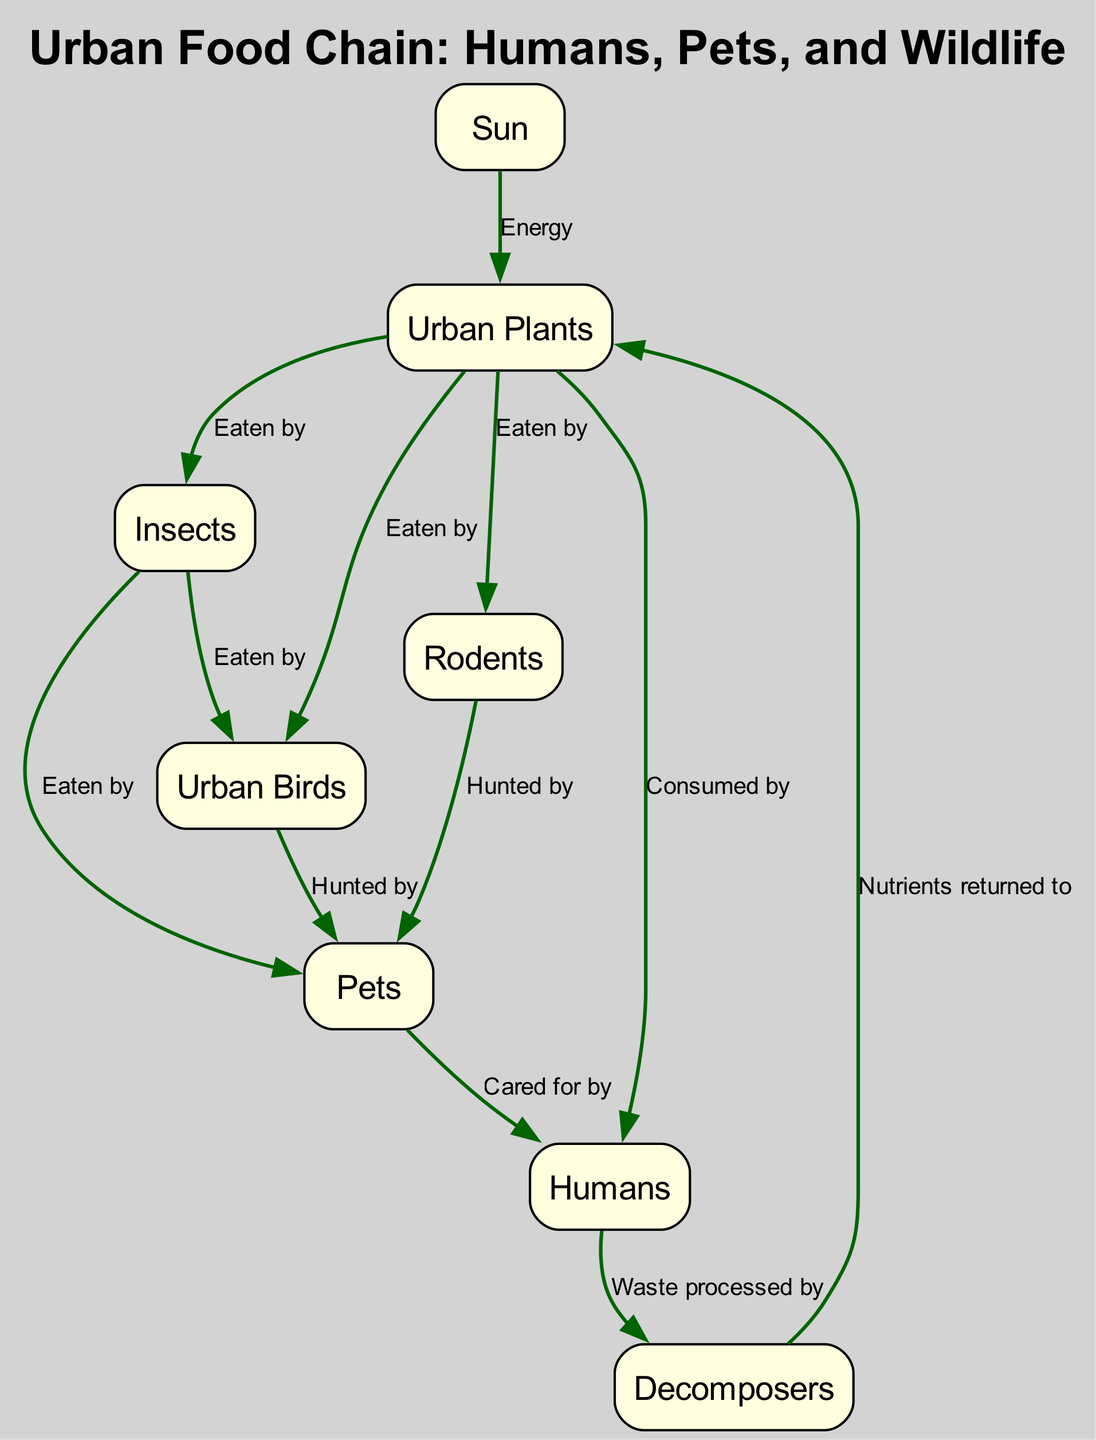What is the primary energy source in the urban food chain? According to the diagram, the primary energy source for all life is indicated as the "Sun." This is the starting point for the food chain and is shown at the top of the diagram.
Answer: Sun How many nodes are present in the urban food chain? The diagram lists a total of seven distinct nodes, which include the Sun, Urban Plants, Insects, Birds, Rodents, Pets, and Humans. Each represents an important element in the food chain.
Answer: 7 What do urban plants provide for insects? The diagram states that urban plants are "Eaten by" insects. This indicates that insects derive their energy and nutrients from consuming urban plants.
Answer: Eaten by Who cares for pets in the urban food chain? The relationship indicated in the diagram shows that pets are "Cared for by" humans. This establishes a direct link where humans take care of their pets in an urban setting.
Answer: Humans What role do decomposers play in the urban food chain? The diagram explains that decomposers process waste from humans, which returns nutrients to plants. This role is crucial as it sustains the cycle of nutrients within the food chain.
Answer: Nutrients returned to Which animals are hunted by pets according to the diagram? The diagram shows that pets hunt both birds and rodents. This illustrates the predatory behavior that pets exhibit towards these urban wildlife elements.
Answer: Birds and Rodents What do humans consume in the urban food chain? The diagram indicates that humans "Consume" urban plants, highlighting their role as primary consumers within the food chain.
Answer: Urban Plants How do nutrients get returned to plants in the urban food chain? According to the diagram, nutrients are returned to plants by decomposers that process waste generated by humans. This connection underlines the recycling of nutrients in the ecosystem.
Answer: Decomposers What type of animals are represented by the "Urban Birds" node? The diagram specifically states that urban birds include pigeons, sparrows, and robins. This classification identifies common bird species found in urban environments.
Answer: Pigeons, sparrows, and robins 